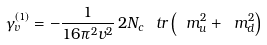Convert formula to latex. <formula><loc_0><loc_0><loc_500><loc_500>\gamma _ { v } ^ { ( 1 ) } = - \frac { 1 } { 1 6 \pi ^ { 2 } v ^ { 2 } } \, 2 N _ { c } \, \ t r \left ( \ m _ { u } ^ { 2 } + \ m _ { d } ^ { 2 } \right )</formula> 